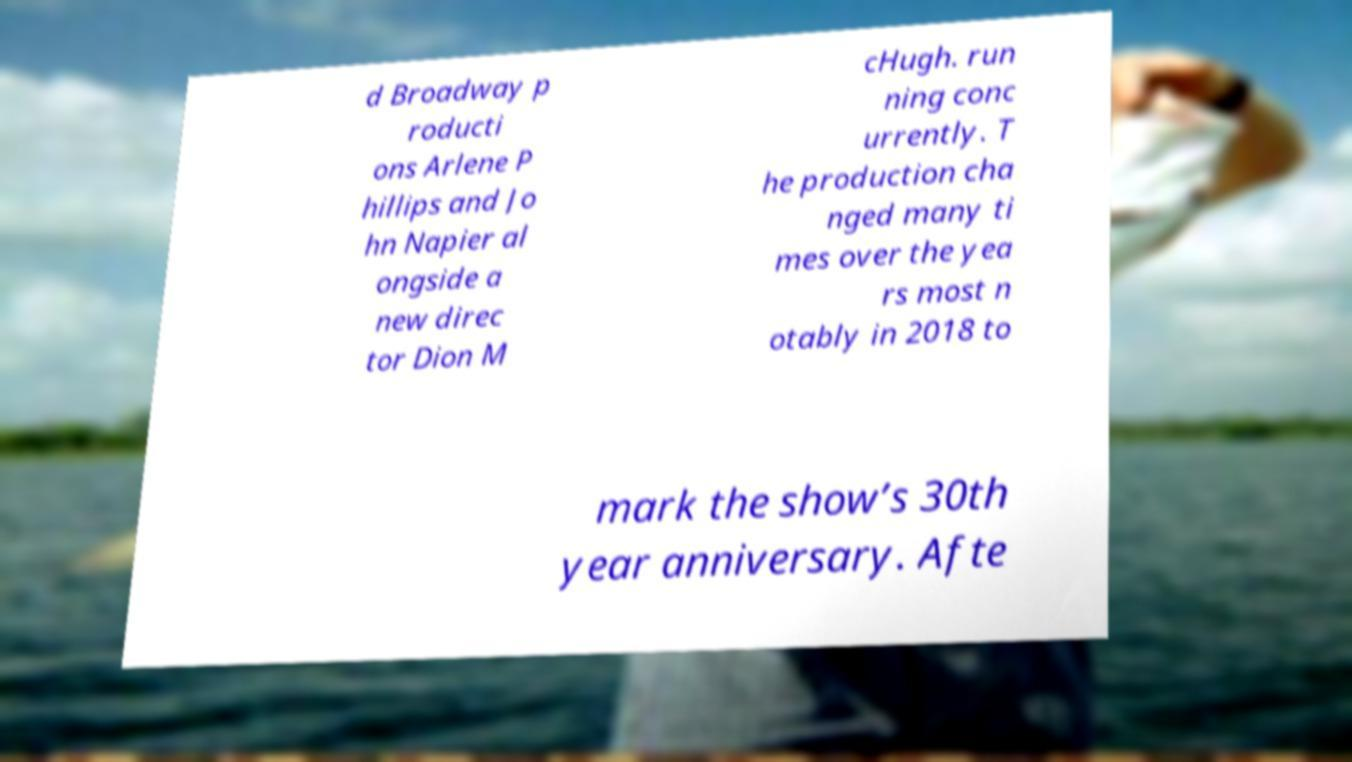What messages or text are displayed in this image? I need them in a readable, typed format. d Broadway p roducti ons Arlene P hillips and Jo hn Napier al ongside a new direc tor Dion M cHugh. run ning conc urrently. T he production cha nged many ti mes over the yea rs most n otably in 2018 to mark the show’s 30th year anniversary. Afte 